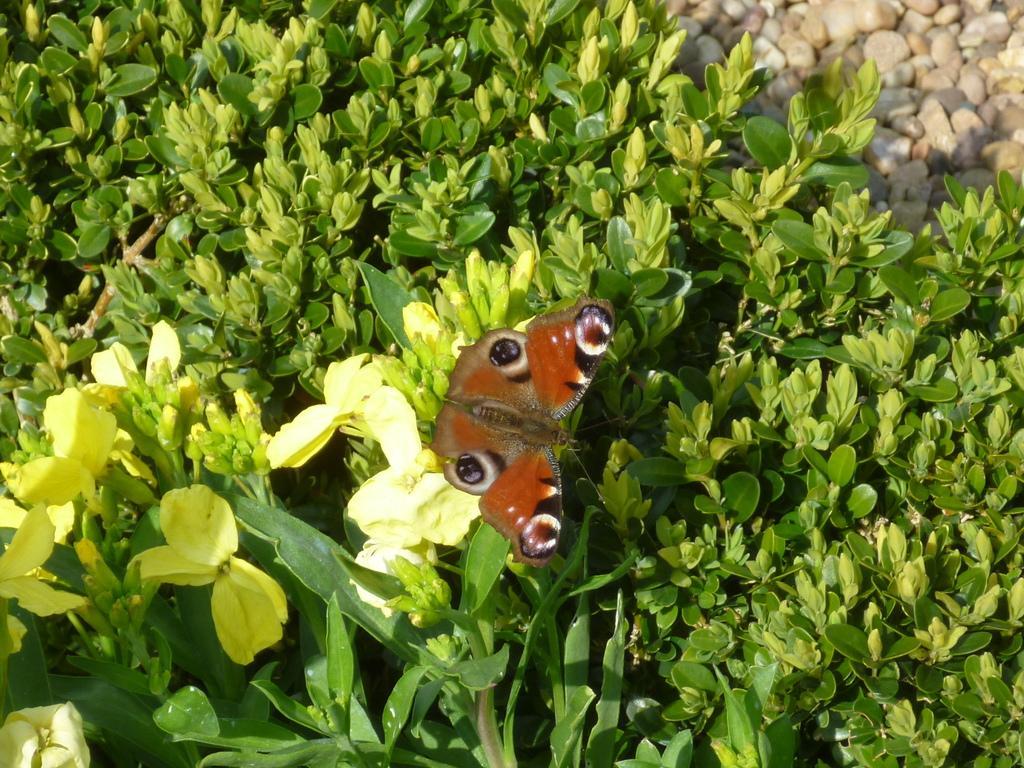Could you give a brief overview of what you see in this image? In this image, I can see a butterfly on a flower and there are plants. At the top right side of the image, I can see the stones. 